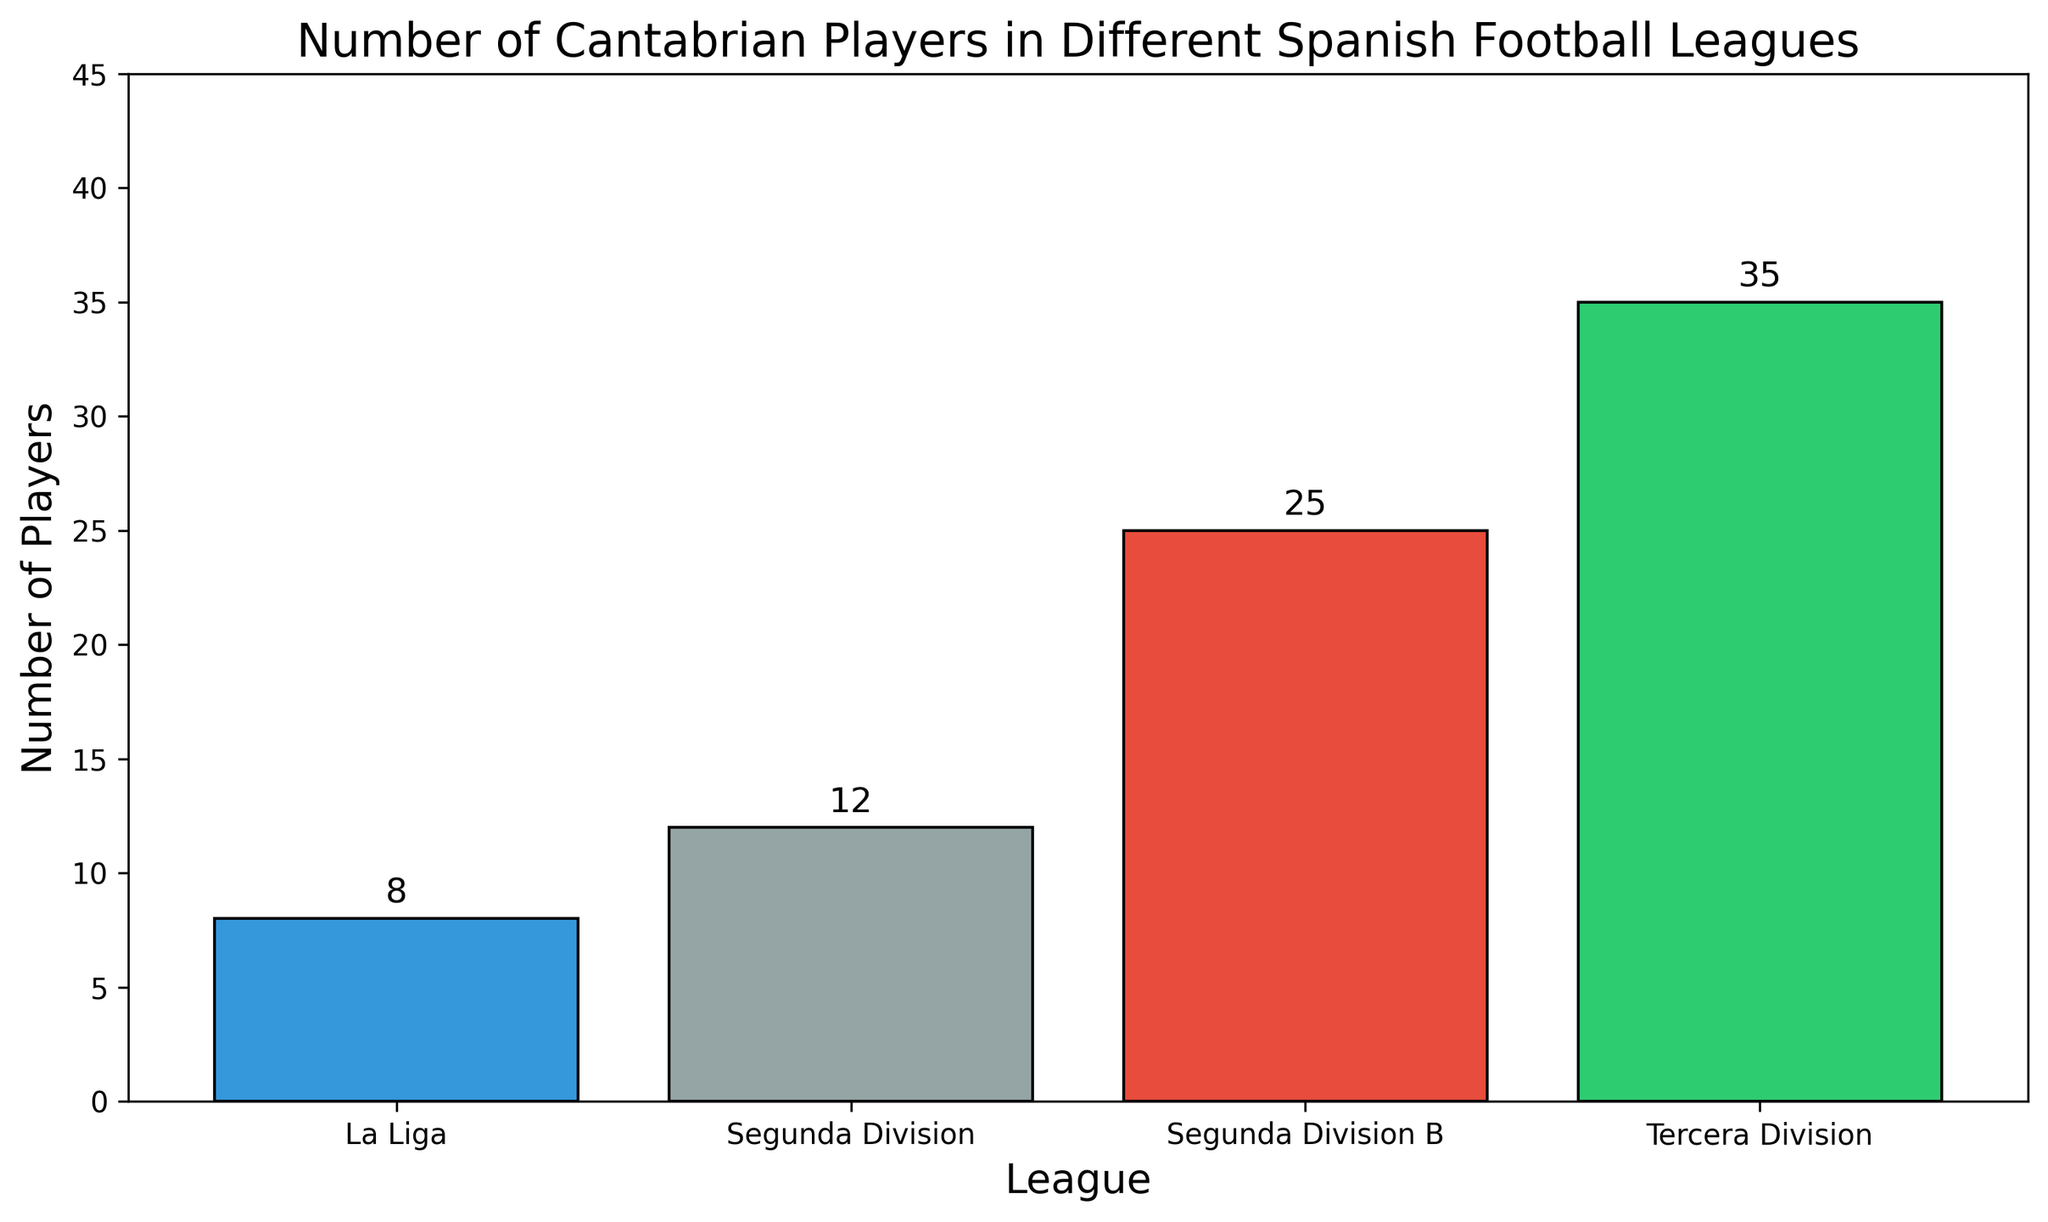Which league has the highest number of Cantabrian players? By looking at the heights of the bars, Tercera Division has the tallest bar, indicating it has the highest number of Cantabrian players.
Answer: Tercera Division Which league has the lowest number of Cantabrian players? By looking at the heights of the bars, La Liga has the shortest bar, indicating it has the lowest number of Cantabrian players.
Answer: La Liga How many Cantabrian players are there in total across all leagues? To find the total, add the number of players from each league: 8 (La Liga) + 12 (Segunda Division) + 25 (Segunda Division B) + 35 (Tercera Division). The total is 80.
Answer: 80 Which league has more Cantabrian players, Segunda Division or Segunda Division B? By comparing the heights of the bars, Segunda Division B has a taller bar than Segunda Division, indicating more players.
Answer: Segunda Division B How many more Cantabrian players are there in Segunda Division B compared to La Liga? Subtract the number of players in La Liga from the number of players in Segunda Division B: 25 (Segunda Division B) - 8 (La Liga). The result is 17.
Answer: 17 Which leagues have fewer than 20 Cantabrian players? By looking at the height of the bars, both La Liga (8) and Segunda Division (12) have fewer than 20 players.
Answer: La Liga, Segunda Division How does the number of players in Segunda Division B compare to Tercera Division? By comparing the heights, Segunda Division B has 25 players, while Tercera Division has 35 players. Tercera Division has 10 more players than Segunda Division B.
Answer: Tercera Division has 10 more players How many Cantabrian players are in leagues above Segunda Division B? Sum the number of players in La Liga and Segunda Division: 8 (La Liga) + 12 (Segunda Division). The total is 20.
Answer: 20 If the number of Cantabrian players in Segunda Division increased by 5, how many players would there be? Add 5 to the current number of players in Segunda Division: 12 + 5. The new total would be 17.
Answer: 17 What is the difference between the number of Cantabrian players in Segunda Division and Tercera Division? Subtract the number of players in Segunda Division from those in Tercera Division: 35 (Tercera Division) - 12 (Segunda Division). The difference is 23.
Answer: 23 